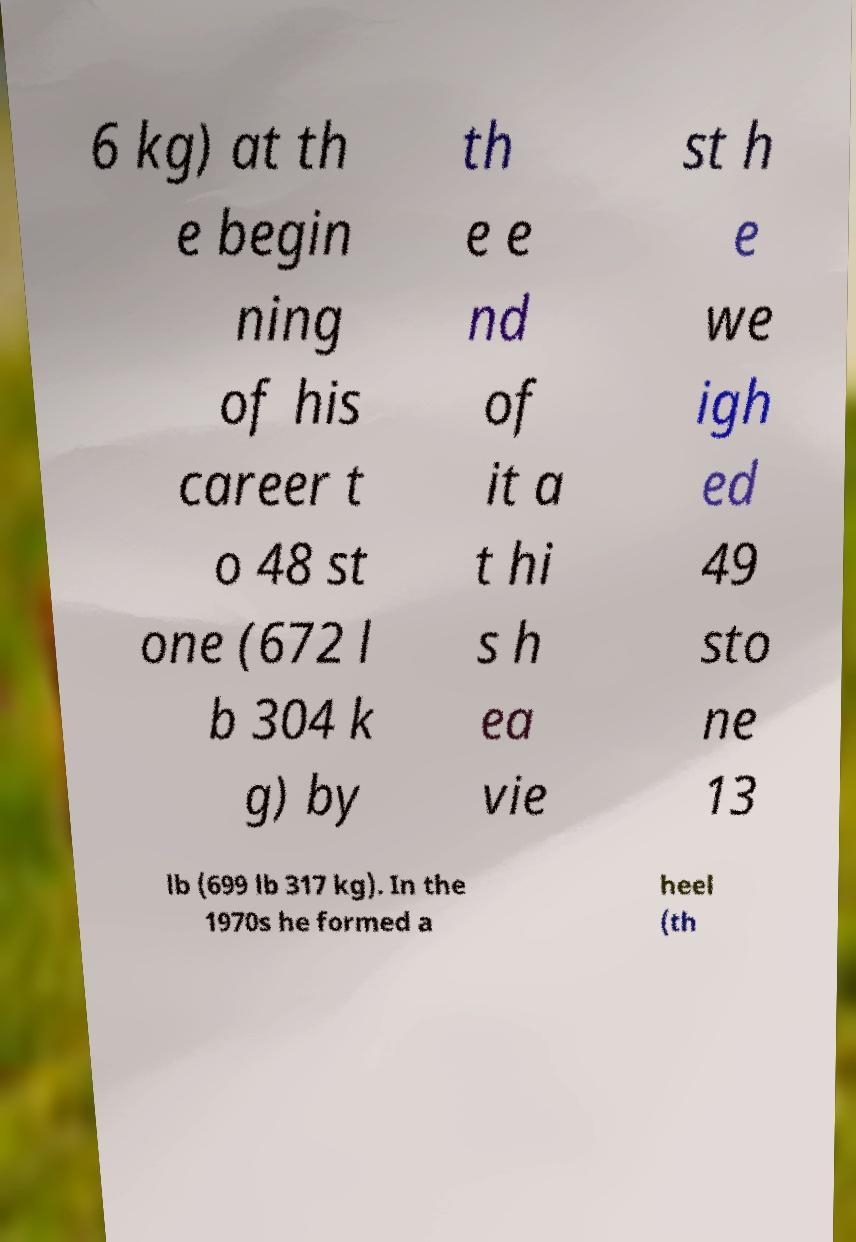Could you extract and type out the text from this image? 6 kg) at th e begin ning of his career t o 48 st one (672 l b 304 k g) by th e e nd of it a t hi s h ea vie st h e we igh ed 49 sto ne 13 lb (699 lb 317 kg). In the 1970s he formed a heel (th 